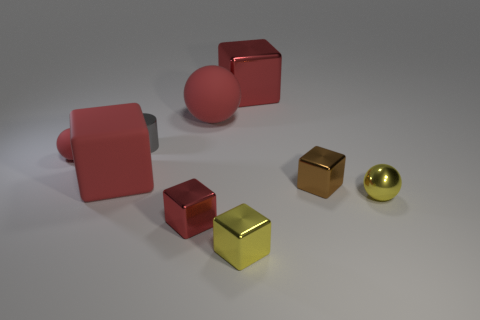How many red blocks must be subtracted to get 1 red blocks? 2 Subtract all matte spheres. How many spheres are left? 1 Subtract all gray cylinders. How many red balls are left? 2 Subtract all yellow blocks. How many blocks are left? 4 Subtract 3 cubes. How many cubes are left? 2 Subtract all gray balls. Subtract all blue cylinders. How many balls are left? 3 Subtract 1 brown cubes. How many objects are left? 8 Subtract all cubes. How many objects are left? 4 Subtract all tiny brown metal balls. Subtract all red balls. How many objects are left? 7 Add 4 metallic objects. How many metallic objects are left? 10 